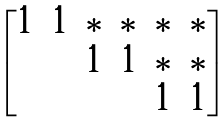<formula> <loc_0><loc_0><loc_500><loc_500>\begin{bmatrix} 1 & 1 & * & * & * & * \\ & & 1 & 1 & * & * \\ & & & & 1 & 1 \end{bmatrix}</formula> 